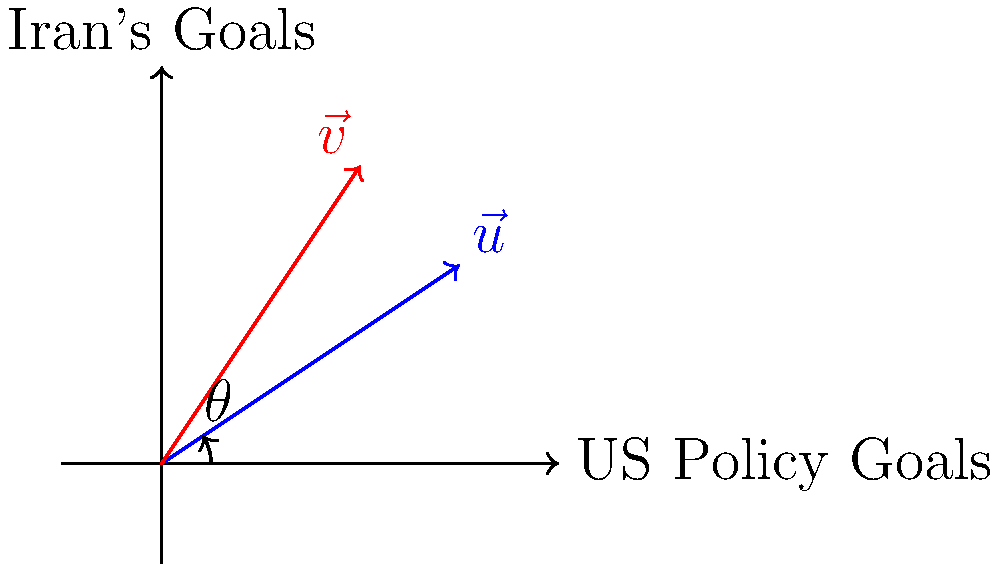Consider the vectors $\vec{u} = (3, 2)$ representing US foreign policy goals and $\vec{v} = (2, 3)$ representing Iran's goals before the Islamic Revolution. Calculate the dot product of these vectors and interpret the result in terms of policy alignment. What does this suggest about the relationship between the US and Iran during the Shah's reign? To analyze the alignment of US foreign policy goals with those of Iran before the Islamic Revolution, we'll use the dot product of the two vectors.

Step 1: Calculate the dot product
$\vec{u} \cdot \vec{v} = (3)(2) + (2)(3) = 6 + 6 = 12$

Step 2: Calculate the magnitudes of the vectors
$|\vec{u}| = \sqrt{3^2 + 2^2} = \sqrt{13}$
$|\vec{v}| = \sqrt{2^2 + 3^2} = \sqrt{13}$

Step 3: Calculate the angle between the vectors using the dot product formula
$\cos \theta = \frac{\vec{u} \cdot \vec{v}}{|\vec{u}||\vec{v}|} = \frac{12}{\sqrt{13}\sqrt{13}} = \frac{12}{13} \approx 0.9231$

Step 4: Convert to degrees
$\theta = \arccos(0.9231) \approx 22.6°$

Interpretation:
1. The dot product is positive (12), indicating a general alignment of goals.
2. The angle between the vectors is small (22.6°), suggesting a strong alignment.
3. This alignment reflects the close relationship between the US and Iran during the Shah's reign, characterized by cooperation in areas such as military, economic, and political spheres.
Answer: Strong alignment (22.6° angle) indicating close US-Iran cooperation during Shah's reign. 